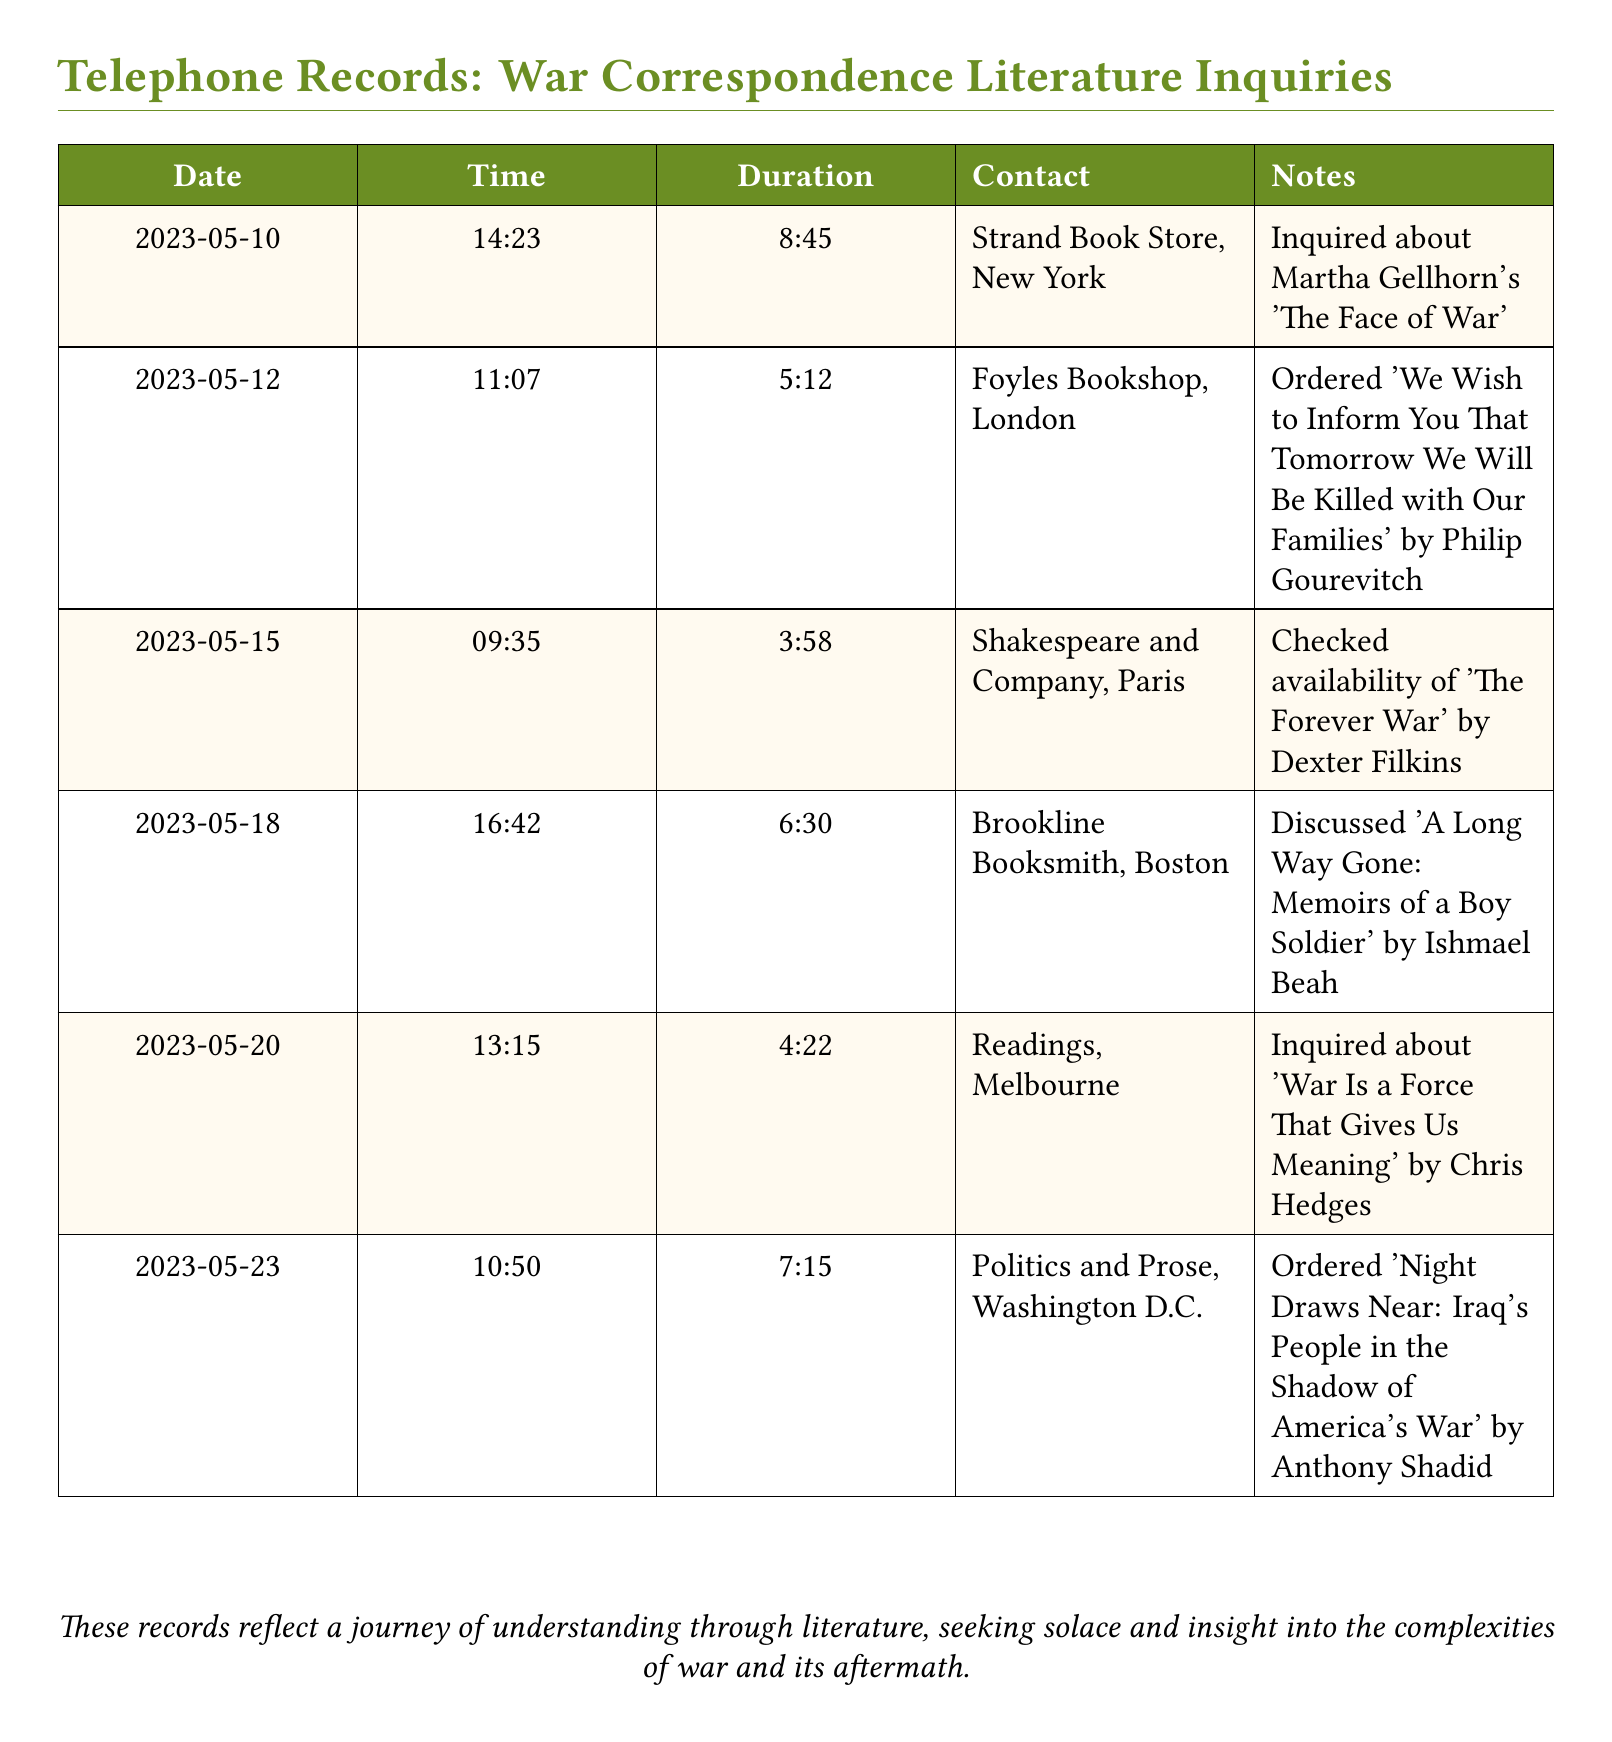What was the first book inquired about? The document states that on May 10, 2023, an inquiry was made about Martha Gellhorn's book 'The Face of War.'
Answer: 'The Face of War' How long was the call made to Foyles Bookshop? The duration of the call on May 12, 2023, was 5 minutes and 12 seconds.
Answer: 5:12 Which bookstore was contacted on May 18, 2023? Referring to the call on that date, the contact was with Brookline Booksmith in Boston.
Answer: Brookline Booksmith, Boston What is the title of the book ordered from Politics and Prose? The document mentions that 'Night Draws Near: Iraq's People in the Shadow of America's War' was ordered from this bookstore.
Answer: 'Night Draws Near: Iraq's People in the Shadow of America's War' How many calls were made regarding books related to war correspondence? The document lists a total of six calls related to war correspondence literature.
Answer: 6 What is the total duration of the call made to Readings? The duration of the call on May 20, 2023, was 4 minutes and 22 seconds.
Answer: 4:22 What was discussed during the call on May 18? The notes indicate that the discussion was about 'A Long Way Gone: Memoirs of a Boy Soldier' by Ishmael Beah.
Answer: 'A Long Way Gone: Memoirs of a Boy Soldier' Which city is Shakespeare and Company located in? The call on May 15, 2023, was made to Shakespeare and Company, which is located in Paris.
Answer: Paris 